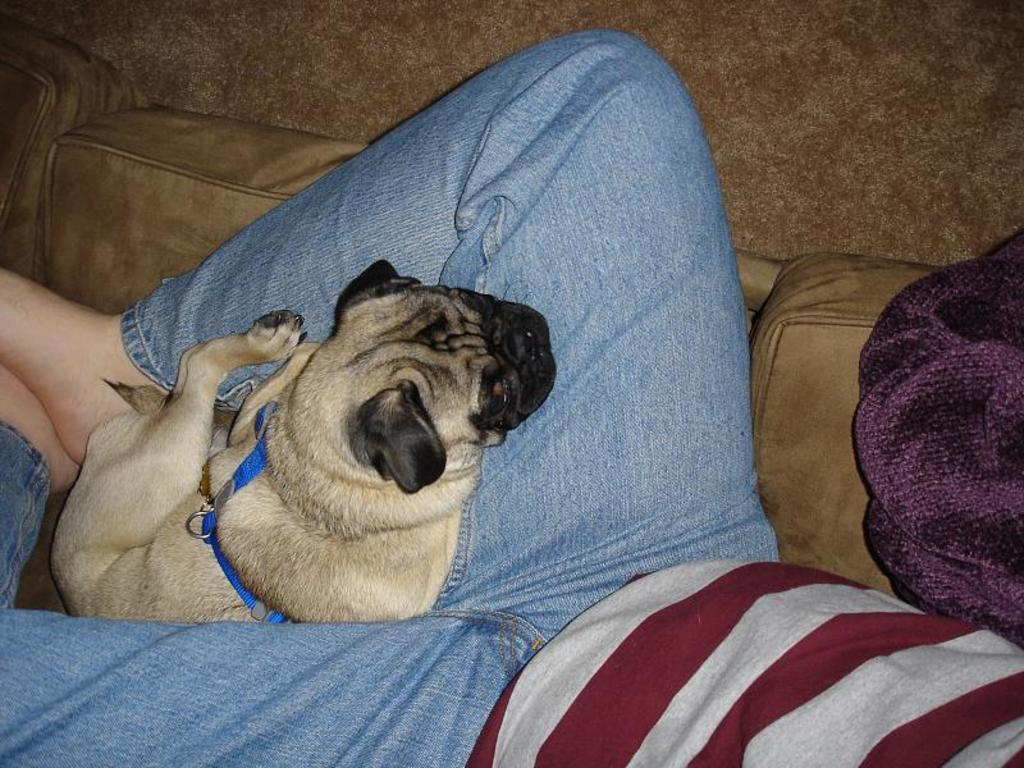What animal is present in the image? There is a dog in the image. What is the dog doing in the image? The dog is on a person. Where is the person located in the image? The person is lying on a sofa. What type of orange tree can be seen in the image? There is no orange tree present in the image; it features a dog on a person lying on a sofa. How many deer are visible in the image? There are no deer present in the image. 